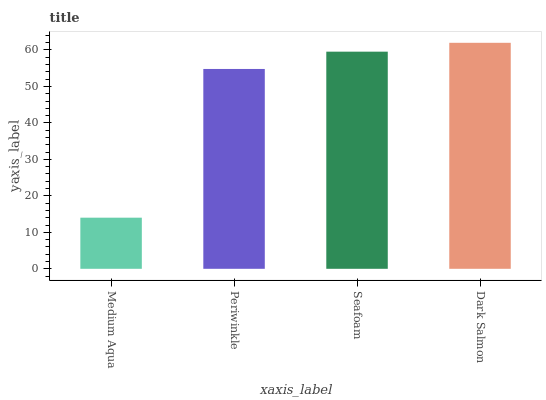Is Medium Aqua the minimum?
Answer yes or no. Yes. Is Dark Salmon the maximum?
Answer yes or no. Yes. Is Periwinkle the minimum?
Answer yes or no. No. Is Periwinkle the maximum?
Answer yes or no. No. Is Periwinkle greater than Medium Aqua?
Answer yes or no. Yes. Is Medium Aqua less than Periwinkle?
Answer yes or no. Yes. Is Medium Aqua greater than Periwinkle?
Answer yes or no. No. Is Periwinkle less than Medium Aqua?
Answer yes or no. No. Is Seafoam the high median?
Answer yes or no. Yes. Is Periwinkle the low median?
Answer yes or no. Yes. Is Dark Salmon the high median?
Answer yes or no. No. Is Medium Aqua the low median?
Answer yes or no. No. 